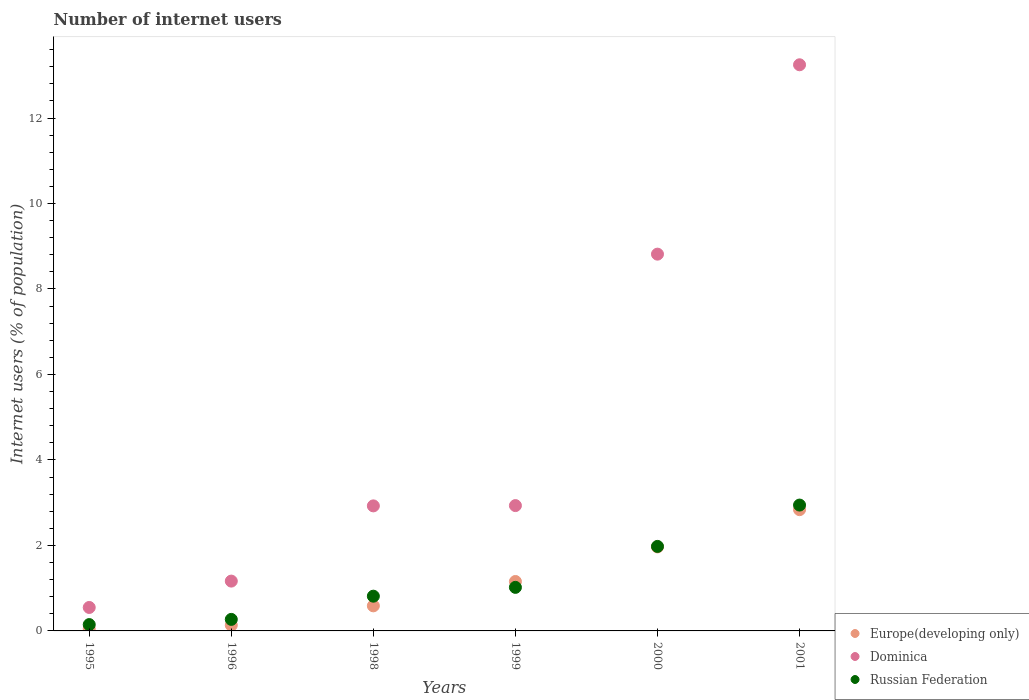How many different coloured dotlines are there?
Your response must be concise. 3. Is the number of dotlines equal to the number of legend labels?
Ensure brevity in your answer.  Yes. What is the number of internet users in Europe(developing only) in 1995?
Provide a succinct answer. 0.05. Across all years, what is the maximum number of internet users in Russian Federation?
Provide a short and direct response. 2.94. Across all years, what is the minimum number of internet users in Russian Federation?
Your answer should be compact. 0.15. What is the total number of internet users in Dominica in the graph?
Offer a very short reply. 29.63. What is the difference between the number of internet users in Russian Federation in 1996 and that in 1998?
Provide a short and direct response. -0.54. What is the difference between the number of internet users in Dominica in 1995 and the number of internet users in Europe(developing only) in 1999?
Your response must be concise. -0.61. What is the average number of internet users in Russian Federation per year?
Ensure brevity in your answer.  1.2. In the year 1996, what is the difference between the number of internet users in Europe(developing only) and number of internet users in Dominica?
Your response must be concise. -1.03. In how many years, is the number of internet users in Europe(developing only) greater than 9.6 %?
Give a very brief answer. 0. What is the ratio of the number of internet users in Dominica in 1998 to that in 2001?
Offer a very short reply. 0.22. What is the difference between the highest and the second highest number of internet users in Europe(developing only)?
Keep it short and to the point. 0.87. What is the difference between the highest and the lowest number of internet users in Europe(developing only)?
Provide a succinct answer. 2.79. Is the sum of the number of internet users in Dominica in 1995 and 2001 greater than the maximum number of internet users in Europe(developing only) across all years?
Provide a short and direct response. Yes. Does the number of internet users in Dominica monotonically increase over the years?
Make the answer very short. Yes. How many dotlines are there?
Provide a succinct answer. 3. How many years are there in the graph?
Offer a terse response. 6. Does the graph contain any zero values?
Offer a very short reply. No. Does the graph contain grids?
Your answer should be compact. No. Where does the legend appear in the graph?
Keep it short and to the point. Bottom right. How are the legend labels stacked?
Offer a very short reply. Vertical. What is the title of the graph?
Keep it short and to the point. Number of internet users. Does "West Bank and Gaza" appear as one of the legend labels in the graph?
Your answer should be very brief. No. What is the label or title of the X-axis?
Offer a very short reply. Years. What is the label or title of the Y-axis?
Ensure brevity in your answer.  Internet users (% of population). What is the Internet users (% of population) of Europe(developing only) in 1995?
Provide a succinct answer. 0.05. What is the Internet users (% of population) of Dominica in 1995?
Offer a terse response. 0.55. What is the Internet users (% of population) in Russian Federation in 1995?
Make the answer very short. 0.15. What is the Internet users (% of population) in Europe(developing only) in 1996?
Make the answer very short. 0.13. What is the Internet users (% of population) of Dominica in 1996?
Provide a short and direct response. 1.17. What is the Internet users (% of population) in Russian Federation in 1996?
Provide a short and direct response. 0.27. What is the Internet users (% of population) in Europe(developing only) in 1998?
Your answer should be compact. 0.59. What is the Internet users (% of population) in Dominica in 1998?
Your answer should be compact. 2.93. What is the Internet users (% of population) of Russian Federation in 1998?
Keep it short and to the point. 0.81. What is the Internet users (% of population) in Europe(developing only) in 1999?
Ensure brevity in your answer.  1.16. What is the Internet users (% of population) in Dominica in 1999?
Your response must be concise. 2.93. What is the Internet users (% of population) in Russian Federation in 1999?
Keep it short and to the point. 1.02. What is the Internet users (% of population) in Europe(developing only) in 2000?
Provide a short and direct response. 1.96. What is the Internet users (% of population) of Dominica in 2000?
Your answer should be very brief. 8.81. What is the Internet users (% of population) in Russian Federation in 2000?
Provide a succinct answer. 1.98. What is the Internet users (% of population) in Europe(developing only) in 2001?
Your answer should be compact. 2.84. What is the Internet users (% of population) in Dominica in 2001?
Your answer should be compact. 13.25. What is the Internet users (% of population) in Russian Federation in 2001?
Provide a succinct answer. 2.94. Across all years, what is the maximum Internet users (% of population) of Europe(developing only)?
Offer a very short reply. 2.84. Across all years, what is the maximum Internet users (% of population) in Dominica?
Offer a very short reply. 13.25. Across all years, what is the maximum Internet users (% of population) in Russian Federation?
Provide a short and direct response. 2.94. Across all years, what is the minimum Internet users (% of population) of Europe(developing only)?
Ensure brevity in your answer.  0.05. Across all years, what is the minimum Internet users (% of population) in Dominica?
Offer a very short reply. 0.55. Across all years, what is the minimum Internet users (% of population) in Russian Federation?
Your response must be concise. 0.15. What is the total Internet users (% of population) in Europe(developing only) in the graph?
Keep it short and to the point. 6.73. What is the total Internet users (% of population) of Dominica in the graph?
Provide a short and direct response. 29.63. What is the total Internet users (% of population) in Russian Federation in the graph?
Make the answer very short. 7.17. What is the difference between the Internet users (% of population) in Europe(developing only) in 1995 and that in 1996?
Give a very brief answer. -0.09. What is the difference between the Internet users (% of population) in Dominica in 1995 and that in 1996?
Keep it short and to the point. -0.62. What is the difference between the Internet users (% of population) of Russian Federation in 1995 and that in 1996?
Provide a succinct answer. -0.12. What is the difference between the Internet users (% of population) of Europe(developing only) in 1995 and that in 1998?
Keep it short and to the point. -0.54. What is the difference between the Internet users (% of population) of Dominica in 1995 and that in 1998?
Keep it short and to the point. -2.38. What is the difference between the Internet users (% of population) in Russian Federation in 1995 and that in 1998?
Make the answer very short. -0.66. What is the difference between the Internet users (% of population) of Europe(developing only) in 1995 and that in 1999?
Offer a very short reply. -1.11. What is the difference between the Internet users (% of population) of Dominica in 1995 and that in 1999?
Give a very brief answer. -2.38. What is the difference between the Internet users (% of population) in Russian Federation in 1995 and that in 1999?
Offer a very short reply. -0.87. What is the difference between the Internet users (% of population) in Europe(developing only) in 1995 and that in 2000?
Ensure brevity in your answer.  -1.92. What is the difference between the Internet users (% of population) in Dominica in 1995 and that in 2000?
Give a very brief answer. -8.27. What is the difference between the Internet users (% of population) of Russian Federation in 1995 and that in 2000?
Make the answer very short. -1.83. What is the difference between the Internet users (% of population) of Europe(developing only) in 1995 and that in 2001?
Your answer should be compact. -2.79. What is the difference between the Internet users (% of population) of Dominica in 1995 and that in 2001?
Provide a short and direct response. -12.7. What is the difference between the Internet users (% of population) in Russian Federation in 1995 and that in 2001?
Ensure brevity in your answer.  -2.8. What is the difference between the Internet users (% of population) of Europe(developing only) in 1996 and that in 1998?
Give a very brief answer. -0.45. What is the difference between the Internet users (% of population) of Dominica in 1996 and that in 1998?
Your answer should be compact. -1.76. What is the difference between the Internet users (% of population) of Russian Federation in 1996 and that in 1998?
Your response must be concise. -0.54. What is the difference between the Internet users (% of population) of Europe(developing only) in 1996 and that in 1999?
Your answer should be very brief. -1.02. What is the difference between the Internet users (% of population) in Dominica in 1996 and that in 1999?
Your response must be concise. -1.77. What is the difference between the Internet users (% of population) of Russian Federation in 1996 and that in 1999?
Provide a short and direct response. -0.75. What is the difference between the Internet users (% of population) of Europe(developing only) in 1996 and that in 2000?
Provide a succinct answer. -1.83. What is the difference between the Internet users (% of population) of Dominica in 1996 and that in 2000?
Give a very brief answer. -7.65. What is the difference between the Internet users (% of population) in Russian Federation in 1996 and that in 2000?
Ensure brevity in your answer.  -1.71. What is the difference between the Internet users (% of population) of Europe(developing only) in 1996 and that in 2001?
Provide a succinct answer. -2.7. What is the difference between the Internet users (% of population) of Dominica in 1996 and that in 2001?
Provide a short and direct response. -12.08. What is the difference between the Internet users (% of population) in Russian Federation in 1996 and that in 2001?
Provide a succinct answer. -2.67. What is the difference between the Internet users (% of population) in Europe(developing only) in 1998 and that in 1999?
Your response must be concise. -0.57. What is the difference between the Internet users (% of population) of Dominica in 1998 and that in 1999?
Offer a very short reply. -0.01. What is the difference between the Internet users (% of population) in Russian Federation in 1998 and that in 1999?
Offer a very short reply. -0.21. What is the difference between the Internet users (% of population) of Europe(developing only) in 1998 and that in 2000?
Provide a short and direct response. -1.38. What is the difference between the Internet users (% of population) in Dominica in 1998 and that in 2000?
Ensure brevity in your answer.  -5.89. What is the difference between the Internet users (% of population) in Russian Federation in 1998 and that in 2000?
Make the answer very short. -1.16. What is the difference between the Internet users (% of population) of Europe(developing only) in 1998 and that in 2001?
Your answer should be very brief. -2.25. What is the difference between the Internet users (% of population) in Dominica in 1998 and that in 2001?
Offer a very short reply. -10.32. What is the difference between the Internet users (% of population) of Russian Federation in 1998 and that in 2001?
Keep it short and to the point. -2.13. What is the difference between the Internet users (% of population) of Europe(developing only) in 1999 and that in 2000?
Your response must be concise. -0.81. What is the difference between the Internet users (% of population) in Dominica in 1999 and that in 2000?
Ensure brevity in your answer.  -5.88. What is the difference between the Internet users (% of population) of Russian Federation in 1999 and that in 2000?
Your answer should be compact. -0.96. What is the difference between the Internet users (% of population) of Europe(developing only) in 1999 and that in 2001?
Offer a terse response. -1.68. What is the difference between the Internet users (% of population) in Dominica in 1999 and that in 2001?
Your response must be concise. -10.31. What is the difference between the Internet users (% of population) in Russian Federation in 1999 and that in 2001?
Your response must be concise. -1.93. What is the difference between the Internet users (% of population) of Europe(developing only) in 2000 and that in 2001?
Your response must be concise. -0.87. What is the difference between the Internet users (% of population) of Dominica in 2000 and that in 2001?
Provide a succinct answer. -4.43. What is the difference between the Internet users (% of population) in Russian Federation in 2000 and that in 2001?
Offer a very short reply. -0.97. What is the difference between the Internet users (% of population) in Europe(developing only) in 1995 and the Internet users (% of population) in Dominica in 1996?
Your response must be concise. -1.12. What is the difference between the Internet users (% of population) in Europe(developing only) in 1995 and the Internet users (% of population) in Russian Federation in 1996?
Ensure brevity in your answer.  -0.22. What is the difference between the Internet users (% of population) in Dominica in 1995 and the Internet users (% of population) in Russian Federation in 1996?
Offer a very short reply. 0.28. What is the difference between the Internet users (% of population) of Europe(developing only) in 1995 and the Internet users (% of population) of Dominica in 1998?
Your answer should be very brief. -2.88. What is the difference between the Internet users (% of population) of Europe(developing only) in 1995 and the Internet users (% of population) of Russian Federation in 1998?
Make the answer very short. -0.76. What is the difference between the Internet users (% of population) in Dominica in 1995 and the Internet users (% of population) in Russian Federation in 1998?
Provide a short and direct response. -0.26. What is the difference between the Internet users (% of population) in Europe(developing only) in 1995 and the Internet users (% of population) in Dominica in 1999?
Provide a short and direct response. -2.88. What is the difference between the Internet users (% of population) in Europe(developing only) in 1995 and the Internet users (% of population) in Russian Federation in 1999?
Make the answer very short. -0.97. What is the difference between the Internet users (% of population) in Dominica in 1995 and the Internet users (% of population) in Russian Federation in 1999?
Give a very brief answer. -0.47. What is the difference between the Internet users (% of population) of Europe(developing only) in 1995 and the Internet users (% of population) of Dominica in 2000?
Provide a short and direct response. -8.77. What is the difference between the Internet users (% of population) in Europe(developing only) in 1995 and the Internet users (% of population) in Russian Federation in 2000?
Offer a very short reply. -1.93. What is the difference between the Internet users (% of population) in Dominica in 1995 and the Internet users (% of population) in Russian Federation in 2000?
Your response must be concise. -1.43. What is the difference between the Internet users (% of population) in Europe(developing only) in 1995 and the Internet users (% of population) in Dominica in 2001?
Keep it short and to the point. -13.2. What is the difference between the Internet users (% of population) of Europe(developing only) in 1995 and the Internet users (% of population) of Russian Federation in 2001?
Offer a terse response. -2.9. What is the difference between the Internet users (% of population) in Dominica in 1995 and the Internet users (% of population) in Russian Federation in 2001?
Provide a short and direct response. -2.4. What is the difference between the Internet users (% of population) of Europe(developing only) in 1996 and the Internet users (% of population) of Dominica in 1998?
Your answer should be compact. -2.79. What is the difference between the Internet users (% of population) of Europe(developing only) in 1996 and the Internet users (% of population) of Russian Federation in 1998?
Provide a short and direct response. -0.68. What is the difference between the Internet users (% of population) of Dominica in 1996 and the Internet users (% of population) of Russian Federation in 1998?
Your answer should be compact. 0.35. What is the difference between the Internet users (% of population) in Europe(developing only) in 1996 and the Internet users (% of population) in Dominica in 1999?
Keep it short and to the point. -2.8. What is the difference between the Internet users (% of population) of Europe(developing only) in 1996 and the Internet users (% of population) of Russian Federation in 1999?
Your response must be concise. -0.89. What is the difference between the Internet users (% of population) of Dominica in 1996 and the Internet users (% of population) of Russian Federation in 1999?
Your answer should be compact. 0.15. What is the difference between the Internet users (% of population) in Europe(developing only) in 1996 and the Internet users (% of population) in Dominica in 2000?
Your answer should be compact. -8.68. What is the difference between the Internet users (% of population) of Europe(developing only) in 1996 and the Internet users (% of population) of Russian Federation in 2000?
Provide a succinct answer. -1.84. What is the difference between the Internet users (% of population) in Dominica in 1996 and the Internet users (% of population) in Russian Federation in 2000?
Your answer should be compact. -0.81. What is the difference between the Internet users (% of population) in Europe(developing only) in 1996 and the Internet users (% of population) in Dominica in 2001?
Give a very brief answer. -13.11. What is the difference between the Internet users (% of population) of Europe(developing only) in 1996 and the Internet users (% of population) of Russian Federation in 2001?
Your answer should be very brief. -2.81. What is the difference between the Internet users (% of population) of Dominica in 1996 and the Internet users (% of population) of Russian Federation in 2001?
Make the answer very short. -1.78. What is the difference between the Internet users (% of population) of Europe(developing only) in 1998 and the Internet users (% of population) of Dominica in 1999?
Make the answer very short. -2.35. What is the difference between the Internet users (% of population) in Europe(developing only) in 1998 and the Internet users (% of population) in Russian Federation in 1999?
Your answer should be compact. -0.43. What is the difference between the Internet users (% of population) in Dominica in 1998 and the Internet users (% of population) in Russian Federation in 1999?
Give a very brief answer. 1.91. What is the difference between the Internet users (% of population) in Europe(developing only) in 1998 and the Internet users (% of population) in Dominica in 2000?
Ensure brevity in your answer.  -8.23. What is the difference between the Internet users (% of population) in Europe(developing only) in 1998 and the Internet users (% of population) in Russian Federation in 2000?
Your answer should be compact. -1.39. What is the difference between the Internet users (% of population) in Dominica in 1998 and the Internet users (% of population) in Russian Federation in 2000?
Your response must be concise. 0.95. What is the difference between the Internet users (% of population) in Europe(developing only) in 1998 and the Internet users (% of population) in Dominica in 2001?
Provide a short and direct response. -12.66. What is the difference between the Internet users (% of population) of Europe(developing only) in 1998 and the Internet users (% of population) of Russian Federation in 2001?
Provide a succinct answer. -2.36. What is the difference between the Internet users (% of population) in Dominica in 1998 and the Internet users (% of population) in Russian Federation in 2001?
Keep it short and to the point. -0.02. What is the difference between the Internet users (% of population) of Europe(developing only) in 1999 and the Internet users (% of population) of Dominica in 2000?
Offer a very short reply. -7.66. What is the difference between the Internet users (% of population) in Europe(developing only) in 1999 and the Internet users (% of population) in Russian Federation in 2000?
Give a very brief answer. -0.82. What is the difference between the Internet users (% of population) of Dominica in 1999 and the Internet users (% of population) of Russian Federation in 2000?
Your response must be concise. 0.95. What is the difference between the Internet users (% of population) in Europe(developing only) in 1999 and the Internet users (% of population) in Dominica in 2001?
Give a very brief answer. -12.09. What is the difference between the Internet users (% of population) in Europe(developing only) in 1999 and the Internet users (% of population) in Russian Federation in 2001?
Offer a terse response. -1.79. What is the difference between the Internet users (% of population) of Dominica in 1999 and the Internet users (% of population) of Russian Federation in 2001?
Offer a terse response. -0.01. What is the difference between the Internet users (% of population) in Europe(developing only) in 2000 and the Internet users (% of population) in Dominica in 2001?
Your answer should be very brief. -11.28. What is the difference between the Internet users (% of population) of Europe(developing only) in 2000 and the Internet users (% of population) of Russian Federation in 2001?
Make the answer very short. -0.98. What is the difference between the Internet users (% of population) of Dominica in 2000 and the Internet users (% of population) of Russian Federation in 2001?
Offer a terse response. 5.87. What is the average Internet users (% of population) in Europe(developing only) per year?
Your answer should be very brief. 1.12. What is the average Internet users (% of population) of Dominica per year?
Offer a very short reply. 4.94. What is the average Internet users (% of population) of Russian Federation per year?
Make the answer very short. 1.2. In the year 1995, what is the difference between the Internet users (% of population) of Europe(developing only) and Internet users (% of population) of Dominica?
Your answer should be compact. -0.5. In the year 1995, what is the difference between the Internet users (% of population) of Europe(developing only) and Internet users (% of population) of Russian Federation?
Ensure brevity in your answer.  -0.1. In the year 1995, what is the difference between the Internet users (% of population) of Dominica and Internet users (% of population) of Russian Federation?
Provide a short and direct response. 0.4. In the year 1996, what is the difference between the Internet users (% of population) of Europe(developing only) and Internet users (% of population) of Dominica?
Make the answer very short. -1.03. In the year 1996, what is the difference between the Internet users (% of population) in Europe(developing only) and Internet users (% of population) in Russian Federation?
Keep it short and to the point. -0.14. In the year 1996, what is the difference between the Internet users (% of population) of Dominica and Internet users (% of population) of Russian Federation?
Your answer should be compact. 0.9. In the year 1998, what is the difference between the Internet users (% of population) in Europe(developing only) and Internet users (% of population) in Dominica?
Keep it short and to the point. -2.34. In the year 1998, what is the difference between the Internet users (% of population) of Europe(developing only) and Internet users (% of population) of Russian Federation?
Your answer should be compact. -0.23. In the year 1998, what is the difference between the Internet users (% of population) in Dominica and Internet users (% of population) in Russian Federation?
Your answer should be compact. 2.11. In the year 1999, what is the difference between the Internet users (% of population) of Europe(developing only) and Internet users (% of population) of Dominica?
Keep it short and to the point. -1.78. In the year 1999, what is the difference between the Internet users (% of population) of Europe(developing only) and Internet users (% of population) of Russian Federation?
Your answer should be very brief. 0.14. In the year 1999, what is the difference between the Internet users (% of population) in Dominica and Internet users (% of population) in Russian Federation?
Provide a short and direct response. 1.91. In the year 2000, what is the difference between the Internet users (% of population) in Europe(developing only) and Internet users (% of population) in Dominica?
Offer a terse response. -6.85. In the year 2000, what is the difference between the Internet users (% of population) in Europe(developing only) and Internet users (% of population) in Russian Federation?
Your response must be concise. -0.01. In the year 2000, what is the difference between the Internet users (% of population) of Dominica and Internet users (% of population) of Russian Federation?
Offer a terse response. 6.84. In the year 2001, what is the difference between the Internet users (% of population) in Europe(developing only) and Internet users (% of population) in Dominica?
Ensure brevity in your answer.  -10.41. In the year 2001, what is the difference between the Internet users (% of population) of Europe(developing only) and Internet users (% of population) of Russian Federation?
Make the answer very short. -0.11. In the year 2001, what is the difference between the Internet users (% of population) of Dominica and Internet users (% of population) of Russian Federation?
Provide a short and direct response. 10.3. What is the ratio of the Internet users (% of population) in Europe(developing only) in 1995 to that in 1996?
Provide a succinct answer. 0.36. What is the ratio of the Internet users (% of population) of Dominica in 1995 to that in 1996?
Give a very brief answer. 0.47. What is the ratio of the Internet users (% of population) of Russian Federation in 1995 to that in 1996?
Give a very brief answer. 0.55. What is the ratio of the Internet users (% of population) of Europe(developing only) in 1995 to that in 1998?
Provide a short and direct response. 0.08. What is the ratio of the Internet users (% of population) in Dominica in 1995 to that in 1998?
Ensure brevity in your answer.  0.19. What is the ratio of the Internet users (% of population) of Russian Federation in 1995 to that in 1998?
Your response must be concise. 0.18. What is the ratio of the Internet users (% of population) of Europe(developing only) in 1995 to that in 1999?
Ensure brevity in your answer.  0.04. What is the ratio of the Internet users (% of population) in Dominica in 1995 to that in 1999?
Ensure brevity in your answer.  0.19. What is the ratio of the Internet users (% of population) in Russian Federation in 1995 to that in 1999?
Ensure brevity in your answer.  0.15. What is the ratio of the Internet users (% of population) of Europe(developing only) in 1995 to that in 2000?
Give a very brief answer. 0.02. What is the ratio of the Internet users (% of population) in Dominica in 1995 to that in 2000?
Ensure brevity in your answer.  0.06. What is the ratio of the Internet users (% of population) of Russian Federation in 1995 to that in 2000?
Keep it short and to the point. 0.07. What is the ratio of the Internet users (% of population) of Europe(developing only) in 1995 to that in 2001?
Make the answer very short. 0.02. What is the ratio of the Internet users (% of population) of Dominica in 1995 to that in 2001?
Offer a very short reply. 0.04. What is the ratio of the Internet users (% of population) in Russian Federation in 1995 to that in 2001?
Ensure brevity in your answer.  0.05. What is the ratio of the Internet users (% of population) of Europe(developing only) in 1996 to that in 1998?
Provide a succinct answer. 0.23. What is the ratio of the Internet users (% of population) of Dominica in 1996 to that in 1998?
Provide a short and direct response. 0.4. What is the ratio of the Internet users (% of population) in Russian Federation in 1996 to that in 1998?
Your response must be concise. 0.33. What is the ratio of the Internet users (% of population) of Europe(developing only) in 1996 to that in 1999?
Give a very brief answer. 0.12. What is the ratio of the Internet users (% of population) in Dominica in 1996 to that in 1999?
Provide a succinct answer. 0.4. What is the ratio of the Internet users (% of population) of Russian Federation in 1996 to that in 1999?
Your answer should be very brief. 0.26. What is the ratio of the Internet users (% of population) in Europe(developing only) in 1996 to that in 2000?
Provide a succinct answer. 0.07. What is the ratio of the Internet users (% of population) of Dominica in 1996 to that in 2000?
Your response must be concise. 0.13. What is the ratio of the Internet users (% of population) in Russian Federation in 1996 to that in 2000?
Provide a short and direct response. 0.14. What is the ratio of the Internet users (% of population) of Europe(developing only) in 1996 to that in 2001?
Make the answer very short. 0.05. What is the ratio of the Internet users (% of population) of Dominica in 1996 to that in 2001?
Ensure brevity in your answer.  0.09. What is the ratio of the Internet users (% of population) of Russian Federation in 1996 to that in 2001?
Make the answer very short. 0.09. What is the ratio of the Internet users (% of population) in Europe(developing only) in 1998 to that in 1999?
Offer a very short reply. 0.51. What is the ratio of the Internet users (% of population) in Dominica in 1998 to that in 1999?
Keep it short and to the point. 1. What is the ratio of the Internet users (% of population) in Russian Federation in 1998 to that in 1999?
Your response must be concise. 0.8. What is the ratio of the Internet users (% of population) of Europe(developing only) in 1998 to that in 2000?
Keep it short and to the point. 0.3. What is the ratio of the Internet users (% of population) of Dominica in 1998 to that in 2000?
Provide a succinct answer. 0.33. What is the ratio of the Internet users (% of population) of Russian Federation in 1998 to that in 2000?
Ensure brevity in your answer.  0.41. What is the ratio of the Internet users (% of population) of Europe(developing only) in 1998 to that in 2001?
Offer a terse response. 0.21. What is the ratio of the Internet users (% of population) in Dominica in 1998 to that in 2001?
Keep it short and to the point. 0.22. What is the ratio of the Internet users (% of population) in Russian Federation in 1998 to that in 2001?
Keep it short and to the point. 0.28. What is the ratio of the Internet users (% of population) of Europe(developing only) in 1999 to that in 2000?
Make the answer very short. 0.59. What is the ratio of the Internet users (% of population) in Dominica in 1999 to that in 2000?
Give a very brief answer. 0.33. What is the ratio of the Internet users (% of population) of Russian Federation in 1999 to that in 2000?
Provide a short and direct response. 0.52. What is the ratio of the Internet users (% of population) in Europe(developing only) in 1999 to that in 2001?
Provide a succinct answer. 0.41. What is the ratio of the Internet users (% of population) in Dominica in 1999 to that in 2001?
Offer a very short reply. 0.22. What is the ratio of the Internet users (% of population) of Russian Federation in 1999 to that in 2001?
Your response must be concise. 0.35. What is the ratio of the Internet users (% of population) in Europe(developing only) in 2000 to that in 2001?
Keep it short and to the point. 0.69. What is the ratio of the Internet users (% of population) of Dominica in 2000 to that in 2001?
Ensure brevity in your answer.  0.67. What is the ratio of the Internet users (% of population) in Russian Federation in 2000 to that in 2001?
Make the answer very short. 0.67. What is the difference between the highest and the second highest Internet users (% of population) of Europe(developing only)?
Your response must be concise. 0.87. What is the difference between the highest and the second highest Internet users (% of population) of Dominica?
Keep it short and to the point. 4.43. What is the difference between the highest and the second highest Internet users (% of population) in Russian Federation?
Ensure brevity in your answer.  0.97. What is the difference between the highest and the lowest Internet users (% of population) in Europe(developing only)?
Ensure brevity in your answer.  2.79. What is the difference between the highest and the lowest Internet users (% of population) in Dominica?
Make the answer very short. 12.7. What is the difference between the highest and the lowest Internet users (% of population) of Russian Federation?
Provide a succinct answer. 2.8. 